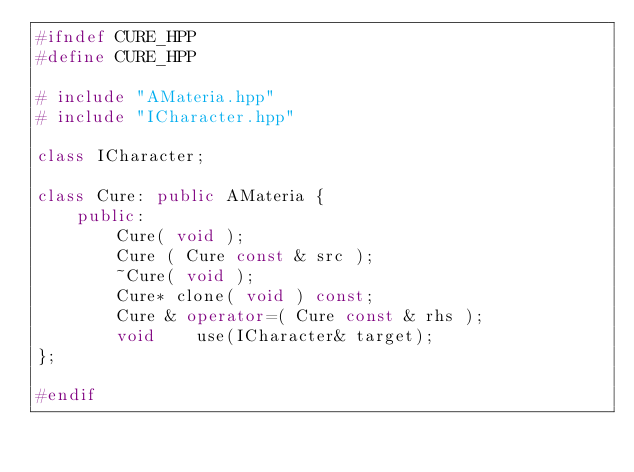Convert code to text. <code><loc_0><loc_0><loc_500><loc_500><_C++_>#ifndef CURE_HPP
#define CURE_HPP

# include "AMateria.hpp"
# include "ICharacter.hpp"

class ICharacter;

class Cure: public AMateria {
	public:
		Cure( void );
		Cure ( Cure const & src );
		~Cure( void );
		Cure* clone( void ) const;
		Cure & operator=( Cure const & rhs );
		void	use(ICharacter& target);
};

#endif
</code> 